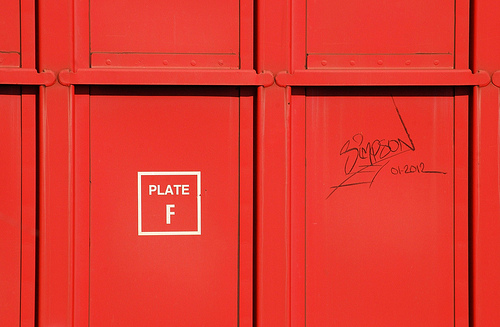<image>
Is there a graffiti under the metal? No. The graffiti is not positioned under the metal. The vertical relationship between these objects is different. 